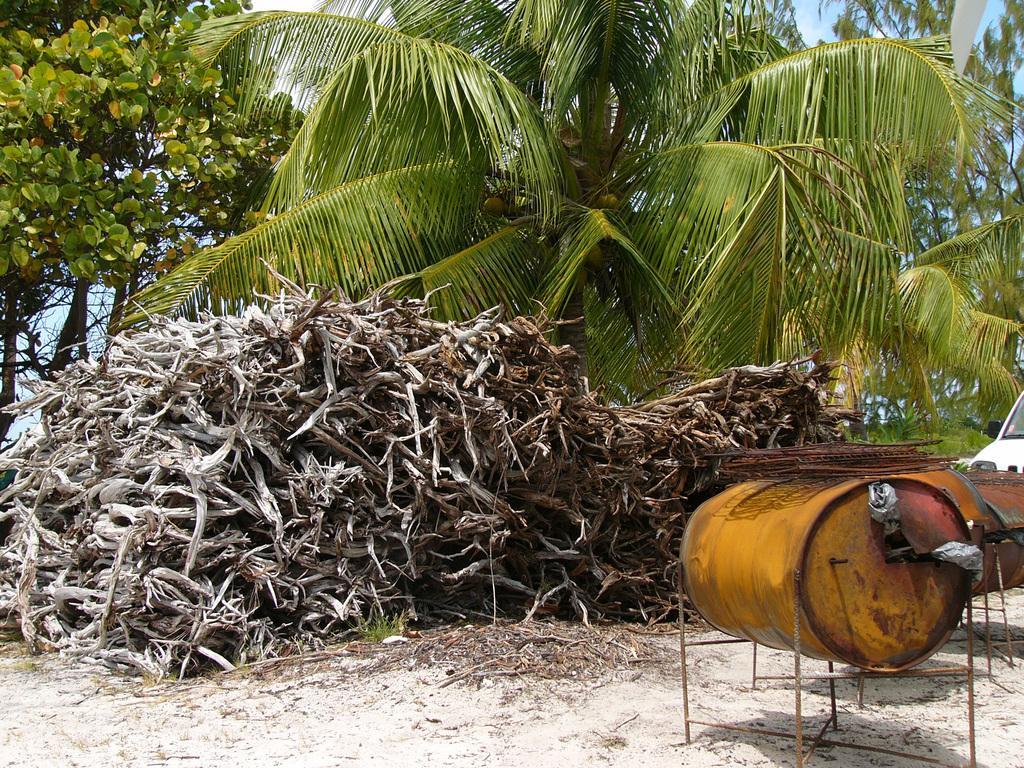Can you describe this image briefly? In this picture there are some dry plants in the front side. Behind there is a green coconut trees. On the right side we can see the yellow color drum. 